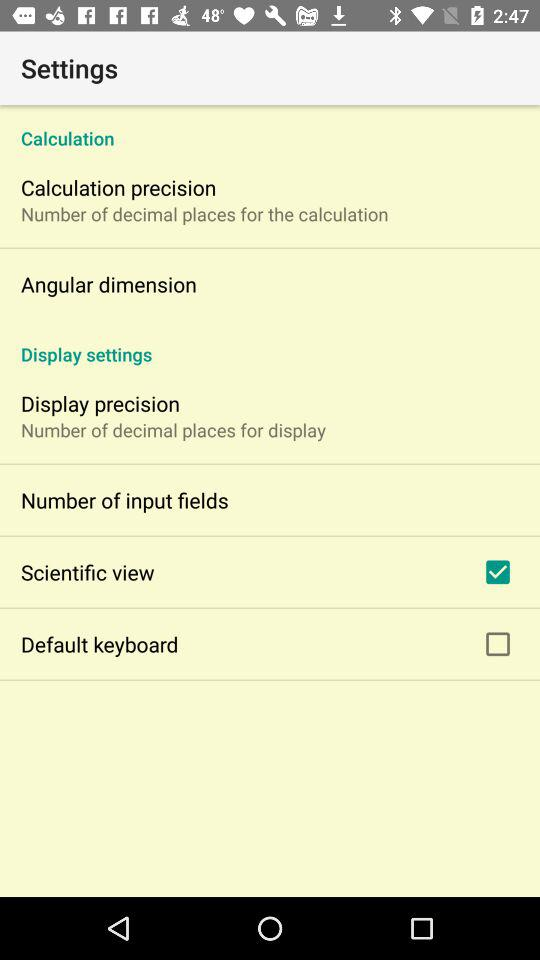Is "Default keyboard" checked or unchecked? "Default keyboard" is unchecked. 